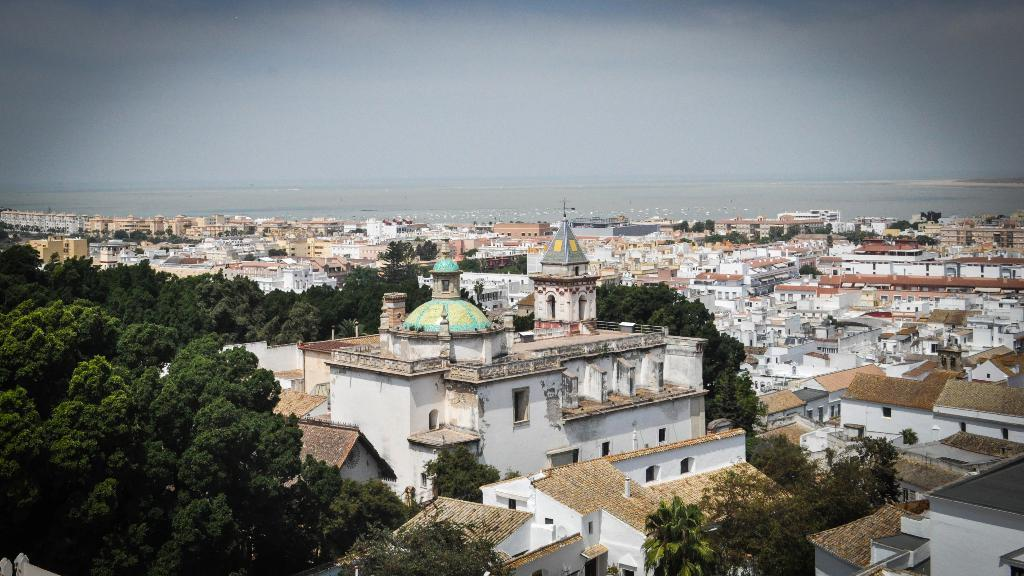What type of natural elements can be seen in the image? There are trees in the image. What type of man-made structures are present in the image? There are buildings in the image. Can you describe any other objects visible in the image? Yes, there are some objects in the image. What can be seen in the background of the image? The sky is visible in the background of the image. How many fish can be seen swimming in the image? There are no fish present in the image. What type of clothing is the scarecrow wearing in the image? There is no scarecrow present in the image. 